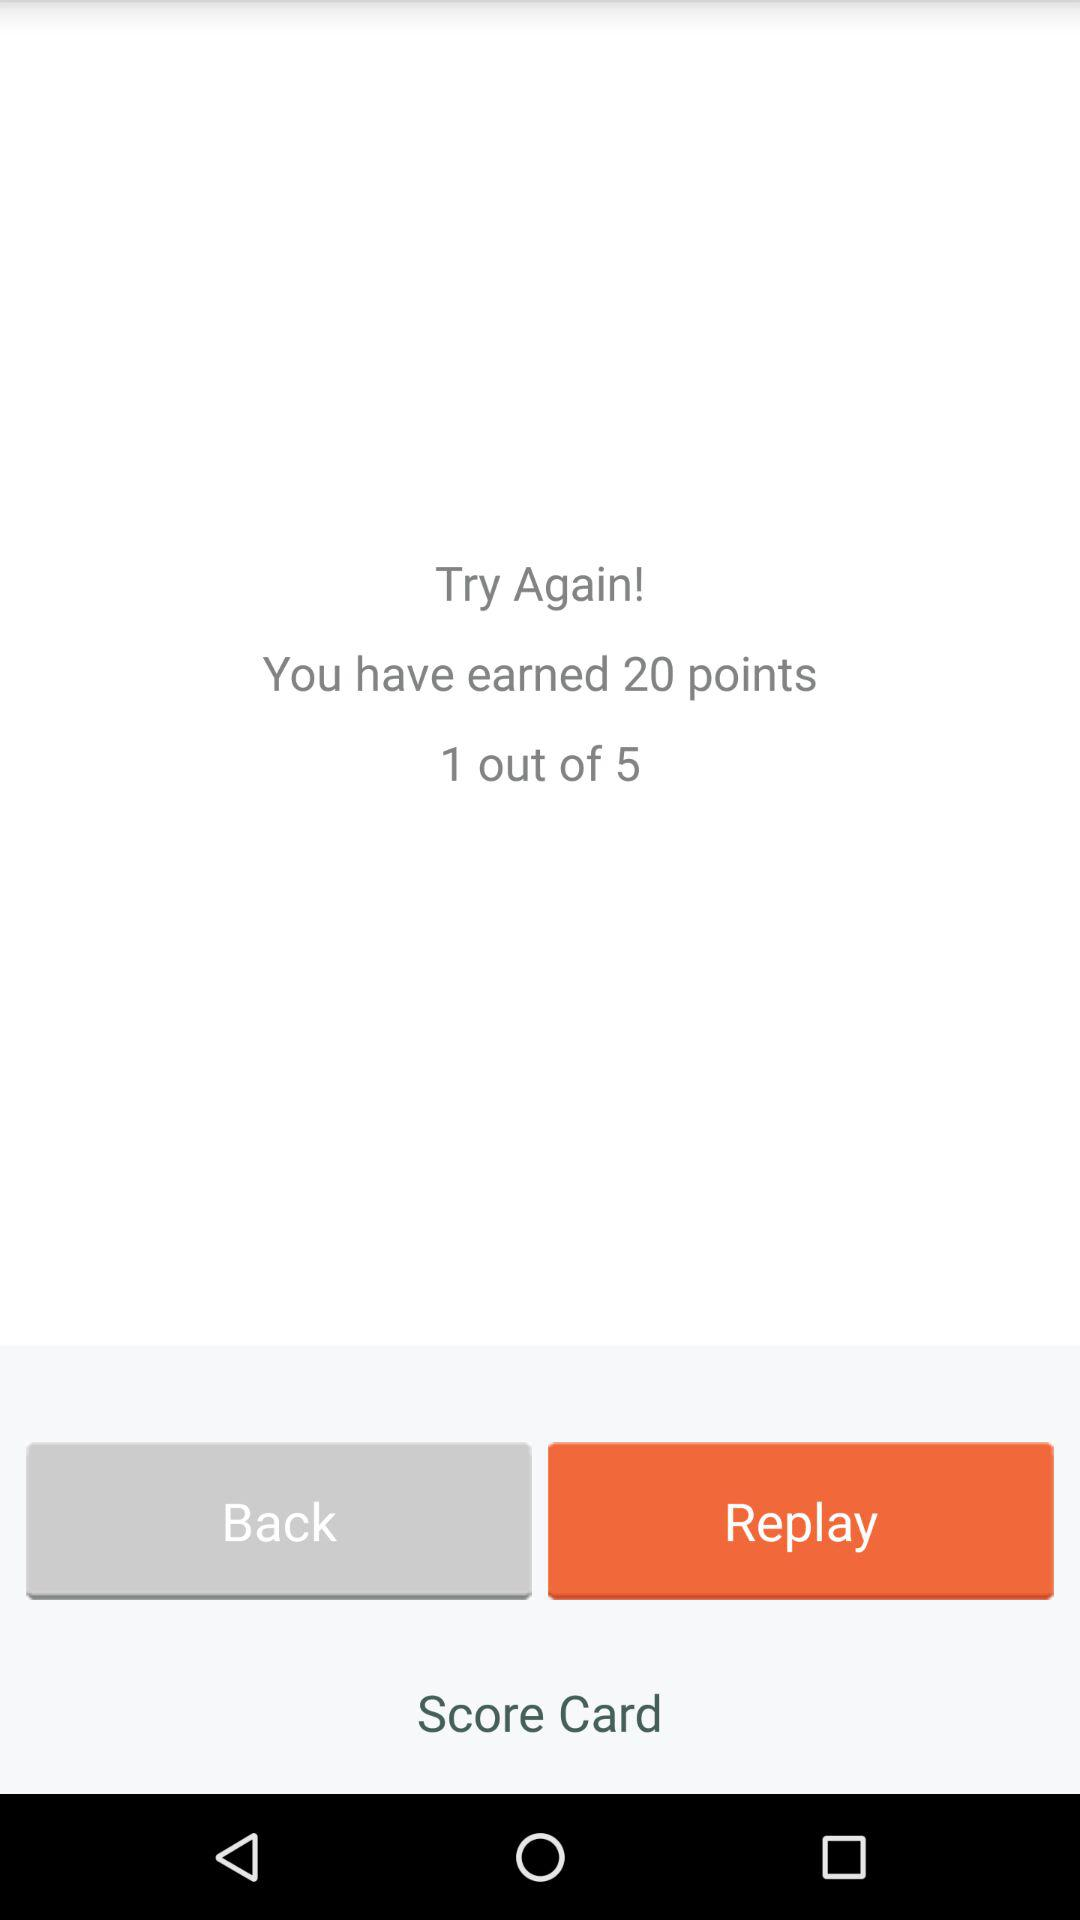How many attempts have been made? There has been 1 attempt made. 